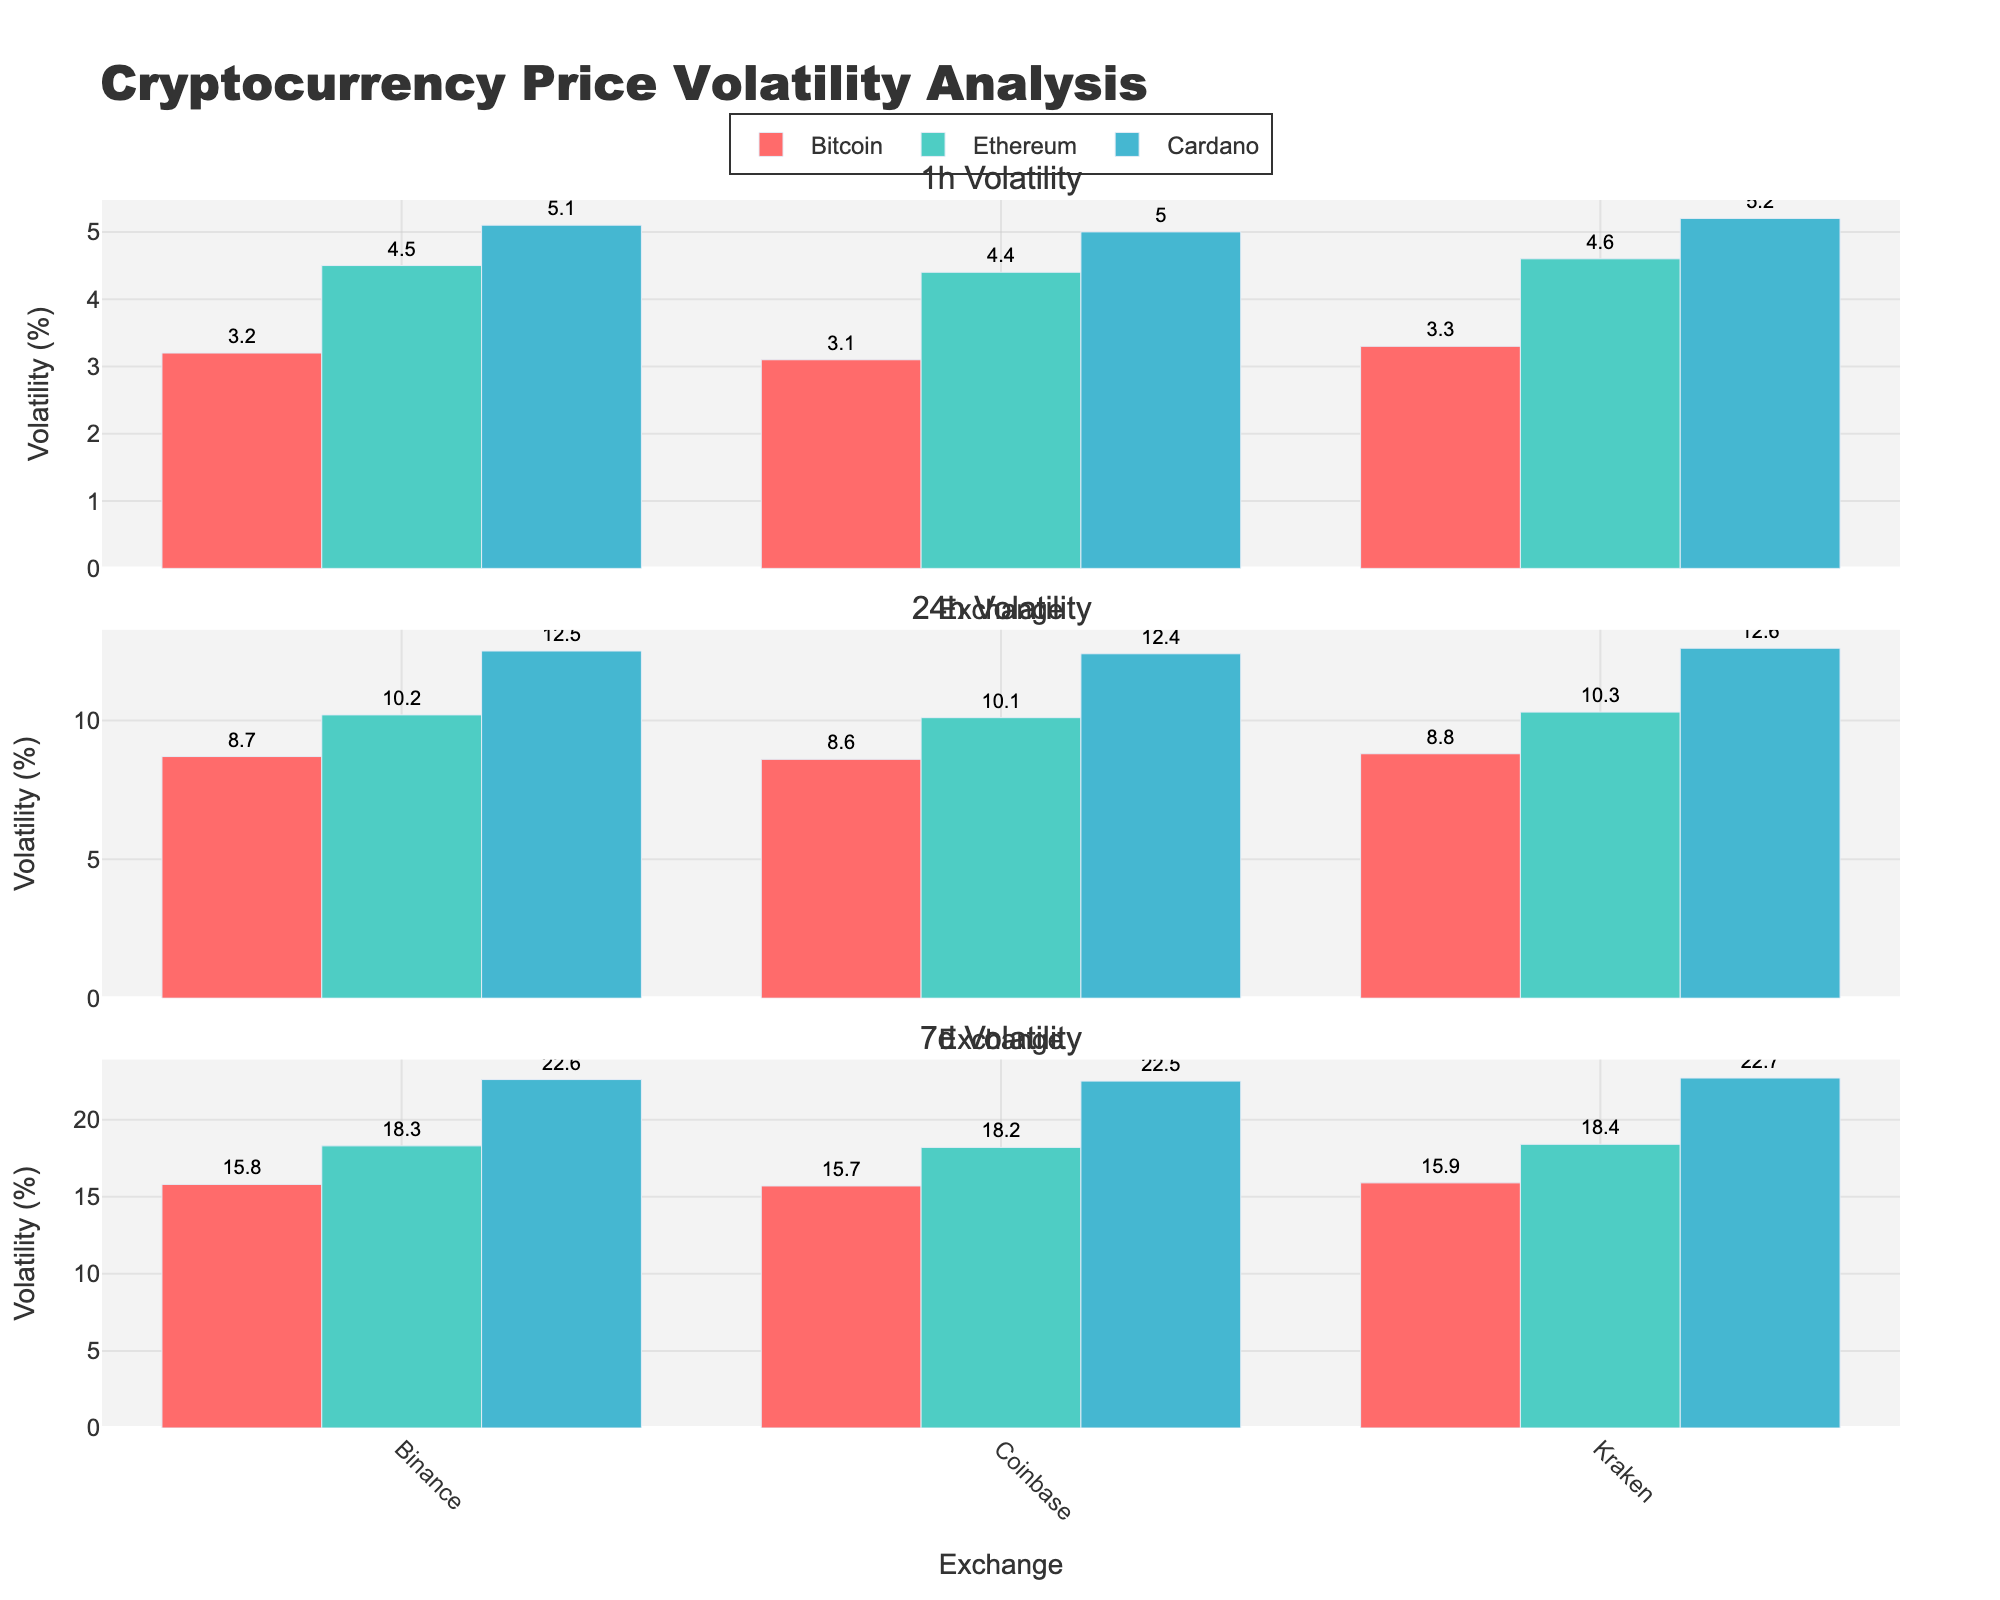What is the title of the figure? The title is positioned at the top of the figure and is meant to give a brief description of the plot. It reads "Cryptocurrency Price Volatility Analysis".
Answer: Cryptocurrency Price Volatility Analysis What does the y-axis represent in all subplots? The y-axis represents the Volatility (%), which is consistent across all the different timeframes shown in the subplots.
Answer: Volatility (%) How many timeframes are presented in the figure, and what are they? There are three timeframes presented in the figure. The subplots are titled "1h Volatility," "24h Volatility," and "7d Volatility," suggesting they represent 1 hour, 24 hours, and 7 days respectively.
Answer: Three: 1 hour, 24 hours, 7 days Which cryptocurrency has the highest volatility in the 1-hour timeframe? In the 1-hour subplot, find the highest bar value among the cryptocurrencies for the exchanges Binance, Coinbase, and Kraken. The highest bar corresponds to Cardano at Kraken with a volatility of 5.2%.
Answer: Cardano For the 24-hour timeframe, which exchange shows the lowest volatility for Bitcoin? In the 24-hour subplot, focus on the specific bars representing Bitcoin across the three exchanges (Binance, Coinbase, Kraken) and find the lowest bar value, which is at Coinbase with a volatility of 8.6%.
Answer: Coinbase What is the difference in Ethereum's volatility between Binance and Kraken in the 7-day timeframe? Locate the bars corresponding to Ethereum in the 7-day subplot, where Binance and Kraken are shown. The volatility values are 18.3% for Binance and 18.4% for Kraken. The difference is calculated as 18.4 - 18.3 = 0.1%.
Answer: 0.1% Compare the volatility of Cardano across the three exchanges in the 24-hour timeframe. Which exchange has the highest volatility? In the 24-hour subplot, check the bars for Cardano across Binance, Coinbase, and Kraken. Kraken shows the highest volatility with a value of 12.6%.
Answer: Kraken Which timeframe shows the highest overall volatility for any cryptocurrency? By examining the maximum bar heights across all subplots, the highest overall volatility is observed in the 7-day timeframe for Cardano at Kraken with a value of 22.7%.
Answer: 7-day What is the average volatility of Bitcoin across all three exchanges in the 1-hour timeframe? Look at the bars representing Bitcoin in the 1-hour subplot on Binance, Coinbase, and Kraken. Sum the values (3.2 + 3.1 + 3.3) and divide by 3 to get the average, which calculates to (9.6 / 3) = 3.2%.
Answer: 3.2% Which cryptocurrency has the least variation in volatility across exchanges in the 24-hour timeframe? Identify the range of volatility for each cryptocurrency in the 24-hour subplot. Cardano has volatility values of 12.5%, 12.4%, and 12.6%, giving a small range (12.6 - 12.4 = 0.2%), indicating the least variability.
Answer: Cardano 